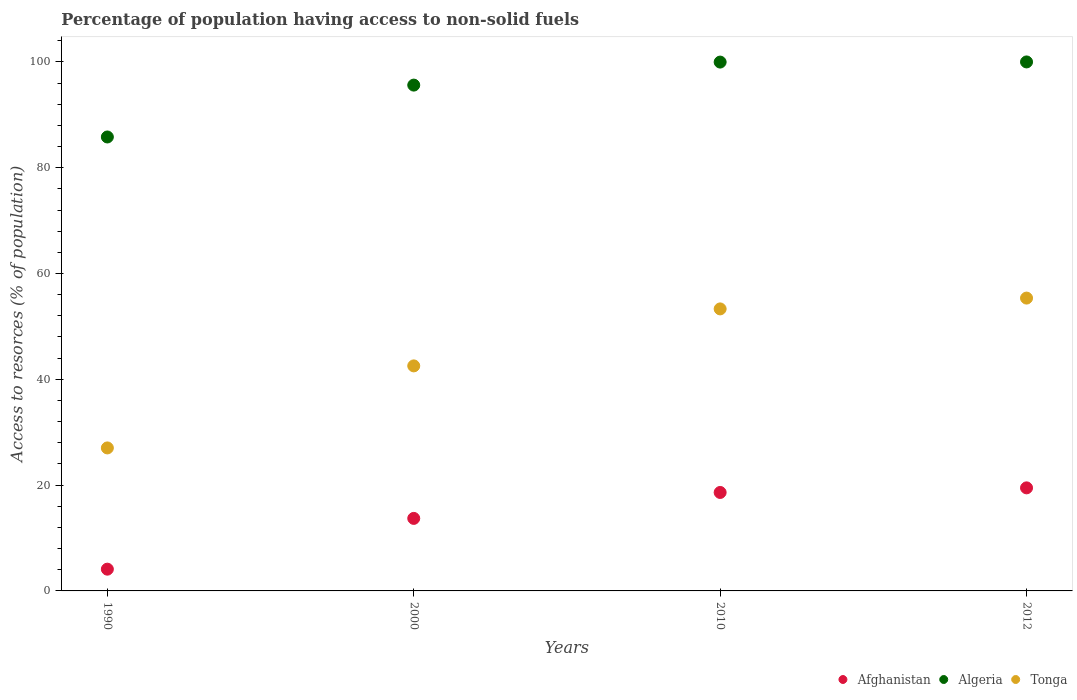How many different coloured dotlines are there?
Ensure brevity in your answer.  3. Is the number of dotlines equal to the number of legend labels?
Provide a short and direct response. Yes. What is the percentage of population having access to non-solid fuels in Algeria in 2000?
Your answer should be very brief. 95.61. Across all years, what is the maximum percentage of population having access to non-solid fuels in Tonga?
Ensure brevity in your answer.  55.35. Across all years, what is the minimum percentage of population having access to non-solid fuels in Tonga?
Your answer should be very brief. 27.03. In which year was the percentage of population having access to non-solid fuels in Algeria maximum?
Ensure brevity in your answer.  2012. What is the total percentage of population having access to non-solid fuels in Algeria in the graph?
Offer a terse response. 381.37. What is the difference between the percentage of population having access to non-solid fuels in Afghanistan in 1990 and that in 2010?
Your answer should be compact. -14.5. What is the difference between the percentage of population having access to non-solid fuels in Tonga in 1990 and the percentage of population having access to non-solid fuels in Afghanistan in 2012?
Your response must be concise. 7.55. What is the average percentage of population having access to non-solid fuels in Algeria per year?
Offer a very short reply. 95.34. In the year 2012, what is the difference between the percentage of population having access to non-solid fuels in Algeria and percentage of population having access to non-solid fuels in Tonga?
Keep it short and to the point. 44.64. What is the ratio of the percentage of population having access to non-solid fuels in Tonga in 2000 to that in 2012?
Your answer should be very brief. 0.77. What is the difference between the highest and the second highest percentage of population having access to non-solid fuels in Afghanistan?
Make the answer very short. 0.87. What is the difference between the highest and the lowest percentage of population having access to non-solid fuels in Afghanistan?
Your answer should be compact. 15.37. Does the percentage of population having access to non-solid fuels in Afghanistan monotonically increase over the years?
Offer a very short reply. Yes. Is the percentage of population having access to non-solid fuels in Algeria strictly greater than the percentage of population having access to non-solid fuels in Tonga over the years?
Keep it short and to the point. Yes. Is the percentage of population having access to non-solid fuels in Afghanistan strictly less than the percentage of population having access to non-solid fuels in Tonga over the years?
Offer a very short reply. Yes. Does the graph contain grids?
Provide a short and direct response. No. What is the title of the graph?
Provide a succinct answer. Percentage of population having access to non-solid fuels. What is the label or title of the Y-axis?
Give a very brief answer. Access to resorces (% of population). What is the Access to resorces (% of population) of Afghanistan in 1990?
Make the answer very short. 4.11. What is the Access to resorces (% of population) of Algeria in 1990?
Offer a terse response. 85.8. What is the Access to resorces (% of population) of Tonga in 1990?
Provide a succinct answer. 27.03. What is the Access to resorces (% of population) of Afghanistan in 2000?
Your answer should be compact. 13.71. What is the Access to resorces (% of population) in Algeria in 2000?
Provide a short and direct response. 95.61. What is the Access to resorces (% of population) of Tonga in 2000?
Your answer should be compact. 42.54. What is the Access to resorces (% of population) in Afghanistan in 2010?
Give a very brief answer. 18.61. What is the Access to resorces (% of population) in Algeria in 2010?
Provide a short and direct response. 99.96. What is the Access to resorces (% of population) of Tonga in 2010?
Keep it short and to the point. 53.31. What is the Access to resorces (% of population) in Afghanistan in 2012?
Provide a succinct answer. 19.48. What is the Access to resorces (% of population) in Algeria in 2012?
Offer a very short reply. 99.99. What is the Access to resorces (% of population) of Tonga in 2012?
Your answer should be compact. 55.35. Across all years, what is the maximum Access to resorces (% of population) in Afghanistan?
Keep it short and to the point. 19.48. Across all years, what is the maximum Access to resorces (% of population) in Algeria?
Offer a terse response. 99.99. Across all years, what is the maximum Access to resorces (% of population) of Tonga?
Your answer should be compact. 55.35. Across all years, what is the minimum Access to resorces (% of population) in Afghanistan?
Keep it short and to the point. 4.11. Across all years, what is the minimum Access to resorces (% of population) in Algeria?
Make the answer very short. 85.8. Across all years, what is the minimum Access to resorces (% of population) in Tonga?
Offer a terse response. 27.03. What is the total Access to resorces (% of population) of Afghanistan in the graph?
Provide a succinct answer. 55.91. What is the total Access to resorces (% of population) in Algeria in the graph?
Ensure brevity in your answer.  381.37. What is the total Access to resorces (% of population) in Tonga in the graph?
Your answer should be very brief. 178.23. What is the difference between the Access to resorces (% of population) of Afghanistan in 1990 and that in 2000?
Offer a terse response. -9.6. What is the difference between the Access to resorces (% of population) of Algeria in 1990 and that in 2000?
Offer a terse response. -9.81. What is the difference between the Access to resorces (% of population) in Tonga in 1990 and that in 2000?
Your answer should be compact. -15.51. What is the difference between the Access to resorces (% of population) of Afghanistan in 1990 and that in 2010?
Keep it short and to the point. -14.5. What is the difference between the Access to resorces (% of population) in Algeria in 1990 and that in 2010?
Your response must be concise. -14.16. What is the difference between the Access to resorces (% of population) in Tonga in 1990 and that in 2010?
Your answer should be compact. -26.28. What is the difference between the Access to resorces (% of population) in Afghanistan in 1990 and that in 2012?
Provide a succinct answer. -15.37. What is the difference between the Access to resorces (% of population) in Algeria in 1990 and that in 2012?
Your response must be concise. -14.19. What is the difference between the Access to resorces (% of population) of Tonga in 1990 and that in 2012?
Your answer should be compact. -28.32. What is the difference between the Access to resorces (% of population) in Afghanistan in 2000 and that in 2010?
Offer a very short reply. -4.9. What is the difference between the Access to resorces (% of population) of Algeria in 2000 and that in 2010?
Offer a very short reply. -4.35. What is the difference between the Access to resorces (% of population) in Tonga in 2000 and that in 2010?
Provide a succinct answer. -10.77. What is the difference between the Access to resorces (% of population) in Afghanistan in 2000 and that in 2012?
Give a very brief answer. -5.77. What is the difference between the Access to resorces (% of population) in Algeria in 2000 and that in 2012?
Provide a short and direct response. -4.38. What is the difference between the Access to resorces (% of population) of Tonga in 2000 and that in 2012?
Offer a very short reply. -12.82. What is the difference between the Access to resorces (% of population) in Afghanistan in 2010 and that in 2012?
Make the answer very short. -0.87. What is the difference between the Access to resorces (% of population) in Algeria in 2010 and that in 2012?
Ensure brevity in your answer.  -0.03. What is the difference between the Access to resorces (% of population) in Tonga in 2010 and that in 2012?
Make the answer very short. -2.04. What is the difference between the Access to resorces (% of population) in Afghanistan in 1990 and the Access to resorces (% of population) in Algeria in 2000?
Make the answer very short. -91.5. What is the difference between the Access to resorces (% of population) of Afghanistan in 1990 and the Access to resorces (% of population) of Tonga in 2000?
Offer a terse response. -38.42. What is the difference between the Access to resorces (% of population) in Algeria in 1990 and the Access to resorces (% of population) in Tonga in 2000?
Offer a very short reply. 43.27. What is the difference between the Access to resorces (% of population) in Afghanistan in 1990 and the Access to resorces (% of population) in Algeria in 2010?
Make the answer very short. -95.85. What is the difference between the Access to resorces (% of population) of Afghanistan in 1990 and the Access to resorces (% of population) of Tonga in 2010?
Provide a succinct answer. -49.2. What is the difference between the Access to resorces (% of population) of Algeria in 1990 and the Access to resorces (% of population) of Tonga in 2010?
Keep it short and to the point. 32.5. What is the difference between the Access to resorces (% of population) of Afghanistan in 1990 and the Access to resorces (% of population) of Algeria in 2012?
Give a very brief answer. -95.88. What is the difference between the Access to resorces (% of population) of Afghanistan in 1990 and the Access to resorces (% of population) of Tonga in 2012?
Offer a terse response. -51.24. What is the difference between the Access to resorces (% of population) of Algeria in 1990 and the Access to resorces (% of population) of Tonga in 2012?
Ensure brevity in your answer.  30.45. What is the difference between the Access to resorces (% of population) in Afghanistan in 2000 and the Access to resorces (% of population) in Algeria in 2010?
Offer a very short reply. -86.25. What is the difference between the Access to resorces (% of population) in Afghanistan in 2000 and the Access to resorces (% of population) in Tonga in 2010?
Make the answer very short. -39.6. What is the difference between the Access to resorces (% of population) of Algeria in 2000 and the Access to resorces (% of population) of Tonga in 2010?
Give a very brief answer. 42.3. What is the difference between the Access to resorces (% of population) of Afghanistan in 2000 and the Access to resorces (% of population) of Algeria in 2012?
Make the answer very short. -86.28. What is the difference between the Access to resorces (% of population) in Afghanistan in 2000 and the Access to resorces (% of population) in Tonga in 2012?
Ensure brevity in your answer.  -41.64. What is the difference between the Access to resorces (% of population) in Algeria in 2000 and the Access to resorces (% of population) in Tonga in 2012?
Keep it short and to the point. 40.26. What is the difference between the Access to resorces (% of population) of Afghanistan in 2010 and the Access to resorces (% of population) of Algeria in 2012?
Your answer should be very brief. -81.38. What is the difference between the Access to resorces (% of population) in Afghanistan in 2010 and the Access to resorces (% of population) in Tonga in 2012?
Make the answer very short. -36.74. What is the difference between the Access to resorces (% of population) in Algeria in 2010 and the Access to resorces (% of population) in Tonga in 2012?
Give a very brief answer. 44.61. What is the average Access to resorces (% of population) of Afghanistan per year?
Your answer should be compact. 13.98. What is the average Access to resorces (% of population) of Algeria per year?
Your response must be concise. 95.34. What is the average Access to resorces (% of population) of Tonga per year?
Provide a short and direct response. 44.56. In the year 1990, what is the difference between the Access to resorces (% of population) of Afghanistan and Access to resorces (% of population) of Algeria?
Offer a terse response. -81.69. In the year 1990, what is the difference between the Access to resorces (% of population) of Afghanistan and Access to resorces (% of population) of Tonga?
Make the answer very short. -22.92. In the year 1990, what is the difference between the Access to resorces (% of population) of Algeria and Access to resorces (% of population) of Tonga?
Give a very brief answer. 58.78. In the year 2000, what is the difference between the Access to resorces (% of population) in Afghanistan and Access to resorces (% of population) in Algeria?
Offer a very short reply. -81.9. In the year 2000, what is the difference between the Access to resorces (% of population) of Afghanistan and Access to resorces (% of population) of Tonga?
Provide a succinct answer. -28.83. In the year 2000, what is the difference between the Access to resorces (% of population) of Algeria and Access to resorces (% of population) of Tonga?
Offer a very short reply. 53.07. In the year 2010, what is the difference between the Access to resorces (% of population) in Afghanistan and Access to resorces (% of population) in Algeria?
Offer a very short reply. -81.35. In the year 2010, what is the difference between the Access to resorces (% of population) of Afghanistan and Access to resorces (% of population) of Tonga?
Give a very brief answer. -34.7. In the year 2010, what is the difference between the Access to resorces (% of population) in Algeria and Access to resorces (% of population) in Tonga?
Make the answer very short. 46.66. In the year 2012, what is the difference between the Access to resorces (% of population) in Afghanistan and Access to resorces (% of population) in Algeria?
Make the answer very short. -80.51. In the year 2012, what is the difference between the Access to resorces (% of population) of Afghanistan and Access to resorces (% of population) of Tonga?
Offer a very short reply. -35.87. In the year 2012, what is the difference between the Access to resorces (% of population) in Algeria and Access to resorces (% of population) in Tonga?
Offer a terse response. 44.64. What is the ratio of the Access to resorces (% of population) in Afghanistan in 1990 to that in 2000?
Your response must be concise. 0.3. What is the ratio of the Access to resorces (% of population) in Algeria in 1990 to that in 2000?
Keep it short and to the point. 0.9. What is the ratio of the Access to resorces (% of population) in Tonga in 1990 to that in 2000?
Ensure brevity in your answer.  0.64. What is the ratio of the Access to resorces (% of population) in Afghanistan in 1990 to that in 2010?
Your response must be concise. 0.22. What is the ratio of the Access to resorces (% of population) in Algeria in 1990 to that in 2010?
Your response must be concise. 0.86. What is the ratio of the Access to resorces (% of population) of Tonga in 1990 to that in 2010?
Make the answer very short. 0.51. What is the ratio of the Access to resorces (% of population) of Afghanistan in 1990 to that in 2012?
Your answer should be very brief. 0.21. What is the ratio of the Access to resorces (% of population) in Algeria in 1990 to that in 2012?
Make the answer very short. 0.86. What is the ratio of the Access to resorces (% of population) in Tonga in 1990 to that in 2012?
Make the answer very short. 0.49. What is the ratio of the Access to resorces (% of population) in Afghanistan in 2000 to that in 2010?
Your answer should be compact. 0.74. What is the ratio of the Access to resorces (% of population) of Algeria in 2000 to that in 2010?
Provide a short and direct response. 0.96. What is the ratio of the Access to resorces (% of population) in Tonga in 2000 to that in 2010?
Your answer should be very brief. 0.8. What is the ratio of the Access to resorces (% of population) of Afghanistan in 2000 to that in 2012?
Your answer should be very brief. 0.7. What is the ratio of the Access to resorces (% of population) in Algeria in 2000 to that in 2012?
Make the answer very short. 0.96. What is the ratio of the Access to resorces (% of population) in Tonga in 2000 to that in 2012?
Give a very brief answer. 0.77. What is the ratio of the Access to resorces (% of population) of Afghanistan in 2010 to that in 2012?
Your answer should be compact. 0.96. What is the ratio of the Access to resorces (% of population) of Algeria in 2010 to that in 2012?
Provide a short and direct response. 1. What is the ratio of the Access to resorces (% of population) of Tonga in 2010 to that in 2012?
Offer a terse response. 0.96. What is the difference between the highest and the second highest Access to resorces (% of population) of Afghanistan?
Offer a very short reply. 0.87. What is the difference between the highest and the second highest Access to resorces (% of population) of Algeria?
Provide a short and direct response. 0.03. What is the difference between the highest and the second highest Access to resorces (% of population) of Tonga?
Your response must be concise. 2.04. What is the difference between the highest and the lowest Access to resorces (% of population) in Afghanistan?
Provide a succinct answer. 15.37. What is the difference between the highest and the lowest Access to resorces (% of population) in Algeria?
Provide a short and direct response. 14.19. What is the difference between the highest and the lowest Access to resorces (% of population) of Tonga?
Your answer should be compact. 28.32. 